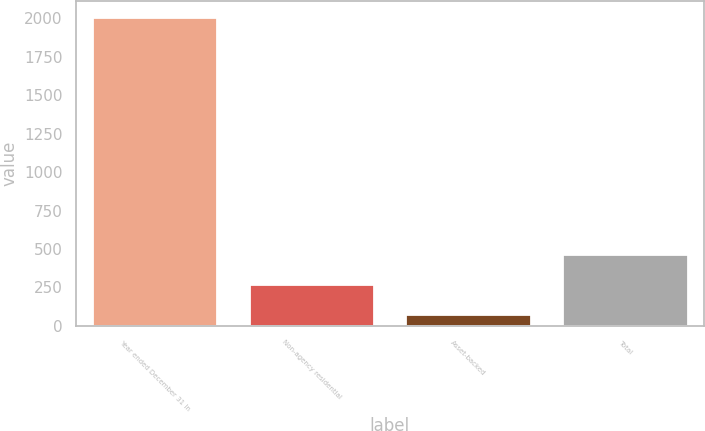Convert chart to OTSL. <chart><loc_0><loc_0><loc_500><loc_500><bar_chart><fcel>Year ended December 31 In<fcel>Non-agency residential<fcel>Asset-backed<fcel>Total<nl><fcel>2010<fcel>271.2<fcel>78<fcel>464.4<nl></chart> 